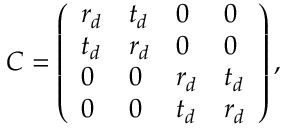<formula> <loc_0><loc_0><loc_500><loc_500>C = \left ( \begin{array} { l l l l } { r _ { d } } & { t _ { d } } & { 0 } & { 0 } \\ { t _ { d } } & { r _ { d } } & { 0 } & { 0 } \\ { 0 } & { 0 } & { r _ { d } } & { t _ { d } } \\ { 0 } & { 0 } & { t _ { d } } & { r _ { d } } \end{array} \right ) ,</formula> 